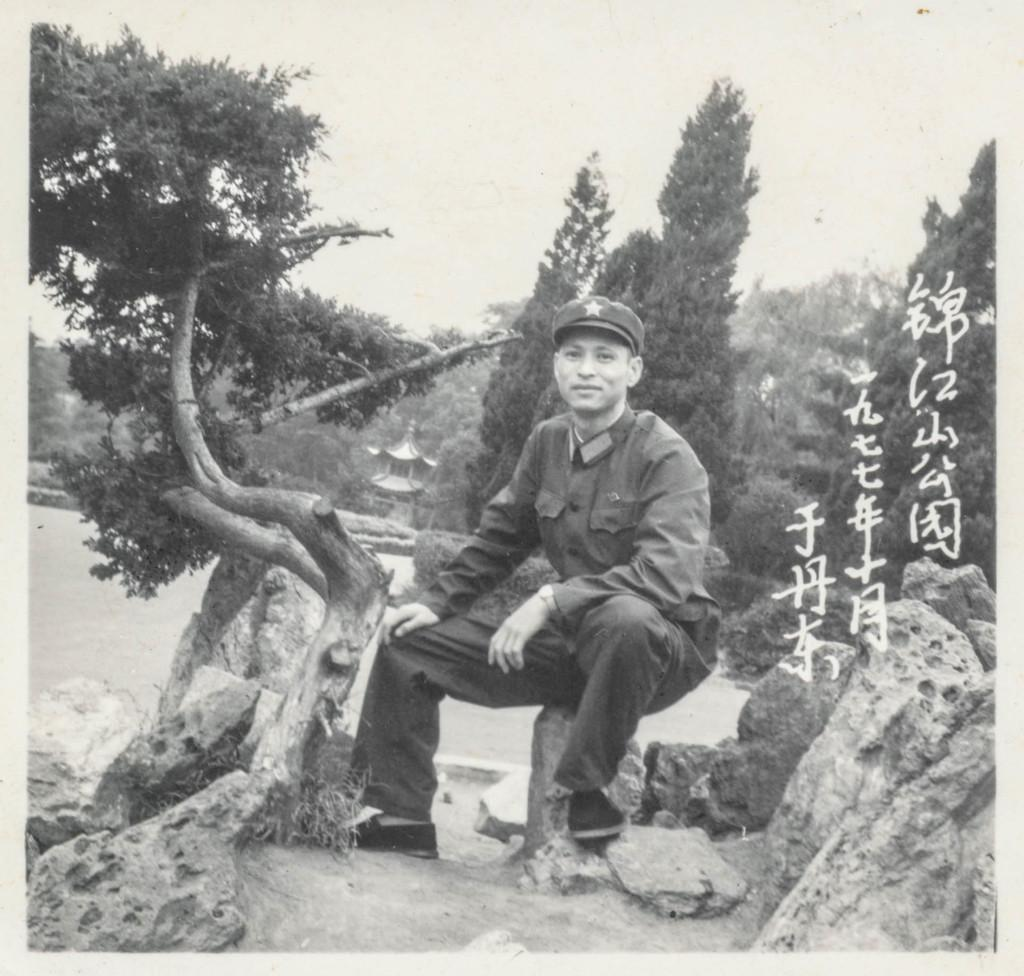What is the person in the image doing? The person is sitting on a rock in the image. What can be seen in the background of the image? There are trees and a building in the background of the image. Is there any additional information about the image itself? Yes, there is a watermark on the image. What type of yam is being cooked in the image? There is no yam or cooking activity present in the image. How much dust can be seen on the person sitting on the rock? The image does not provide information about the presence of dust on the person or any other surface. 